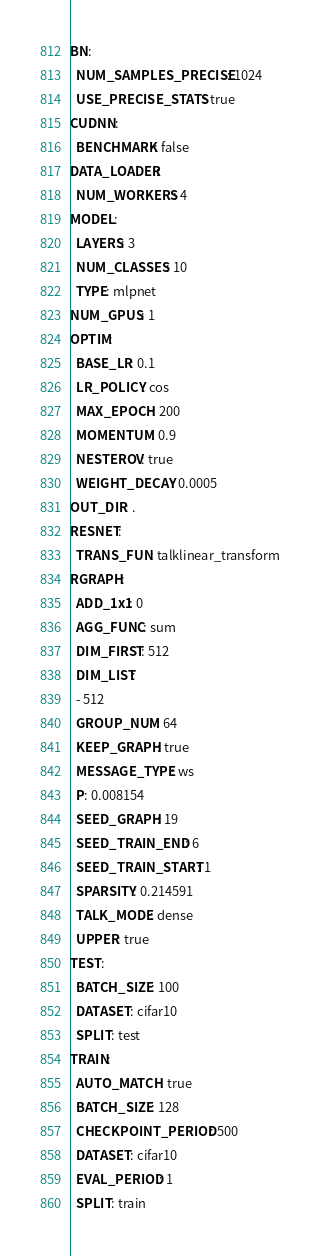Convert code to text. <code><loc_0><loc_0><loc_500><loc_500><_YAML_>BN:
  NUM_SAMPLES_PRECISE: 1024
  USE_PRECISE_STATS: true
CUDNN:
  BENCHMARK: false
DATA_LOADER:
  NUM_WORKERS: 4
MODEL:
  LAYERS: 3
  NUM_CLASSES: 10
  TYPE: mlpnet
NUM_GPUS: 1
OPTIM:
  BASE_LR: 0.1
  LR_POLICY: cos
  MAX_EPOCH: 200
  MOMENTUM: 0.9
  NESTEROV: true
  WEIGHT_DECAY: 0.0005
OUT_DIR: .
RESNET:
  TRANS_FUN: talklinear_transform
RGRAPH:
  ADD_1x1: 0
  AGG_FUNC: sum
  DIM_FIRST: 512
  DIM_LIST:
  - 512
  GROUP_NUM: 64
  KEEP_GRAPH: true
  MESSAGE_TYPE: ws
  P: 0.008154
  SEED_GRAPH: 19
  SEED_TRAIN_END: 6
  SEED_TRAIN_START: 1
  SPARSITY: 0.214591
  TALK_MODE: dense
  UPPER: true
TEST:
  BATCH_SIZE: 100
  DATASET: cifar10
  SPLIT: test
TRAIN:
  AUTO_MATCH: true
  BATCH_SIZE: 128
  CHECKPOINT_PERIOD: 500
  DATASET: cifar10
  EVAL_PERIOD: 1
  SPLIT: train
</code> 